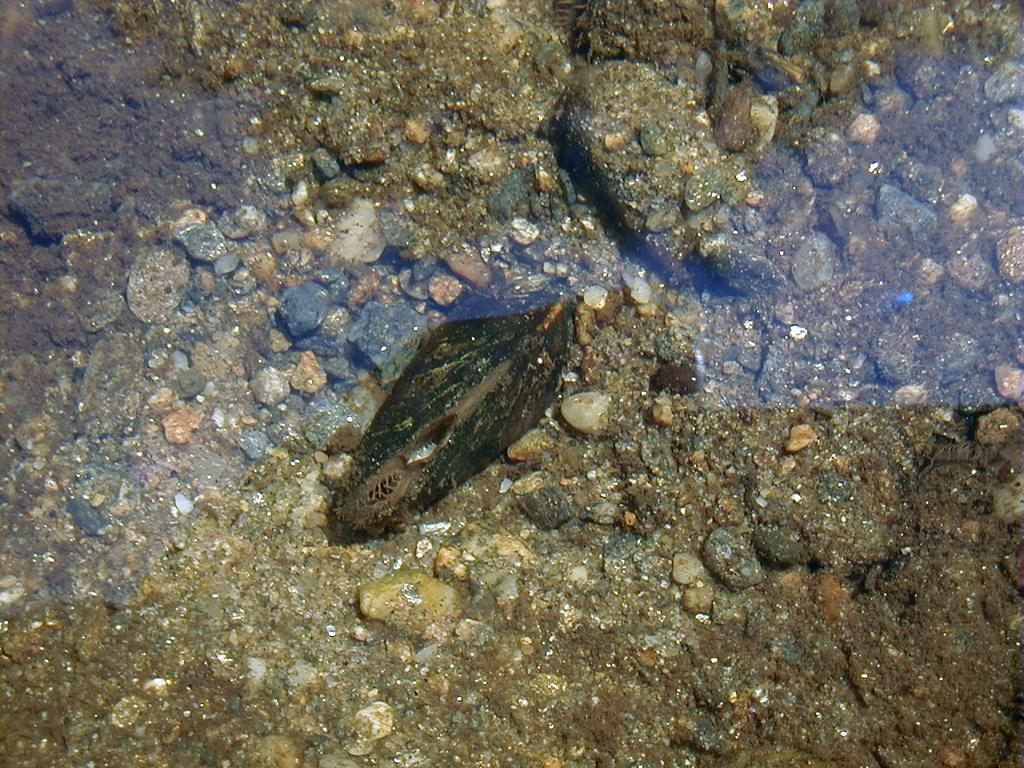What type of animal can be seen in the water in the image? There is an animal in the water in the image. What else is present in the water in the image? There are stones in the water. Where is the drain located in the image? There is no drain present in the image. What type of drawer can be seen in the image? There is no drawer present in the image. 